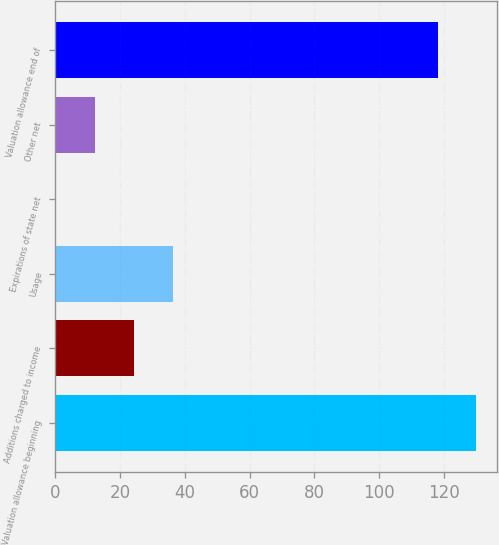<chart> <loc_0><loc_0><loc_500><loc_500><bar_chart><fcel>Valuation allowance beginning<fcel>Additions charged to income<fcel>Usage<fcel>Expirations of state net<fcel>Other net<fcel>Valuation allowance end of<nl><fcel>130.08<fcel>24.26<fcel>36.24<fcel>0.3<fcel>12.28<fcel>118.1<nl></chart> 